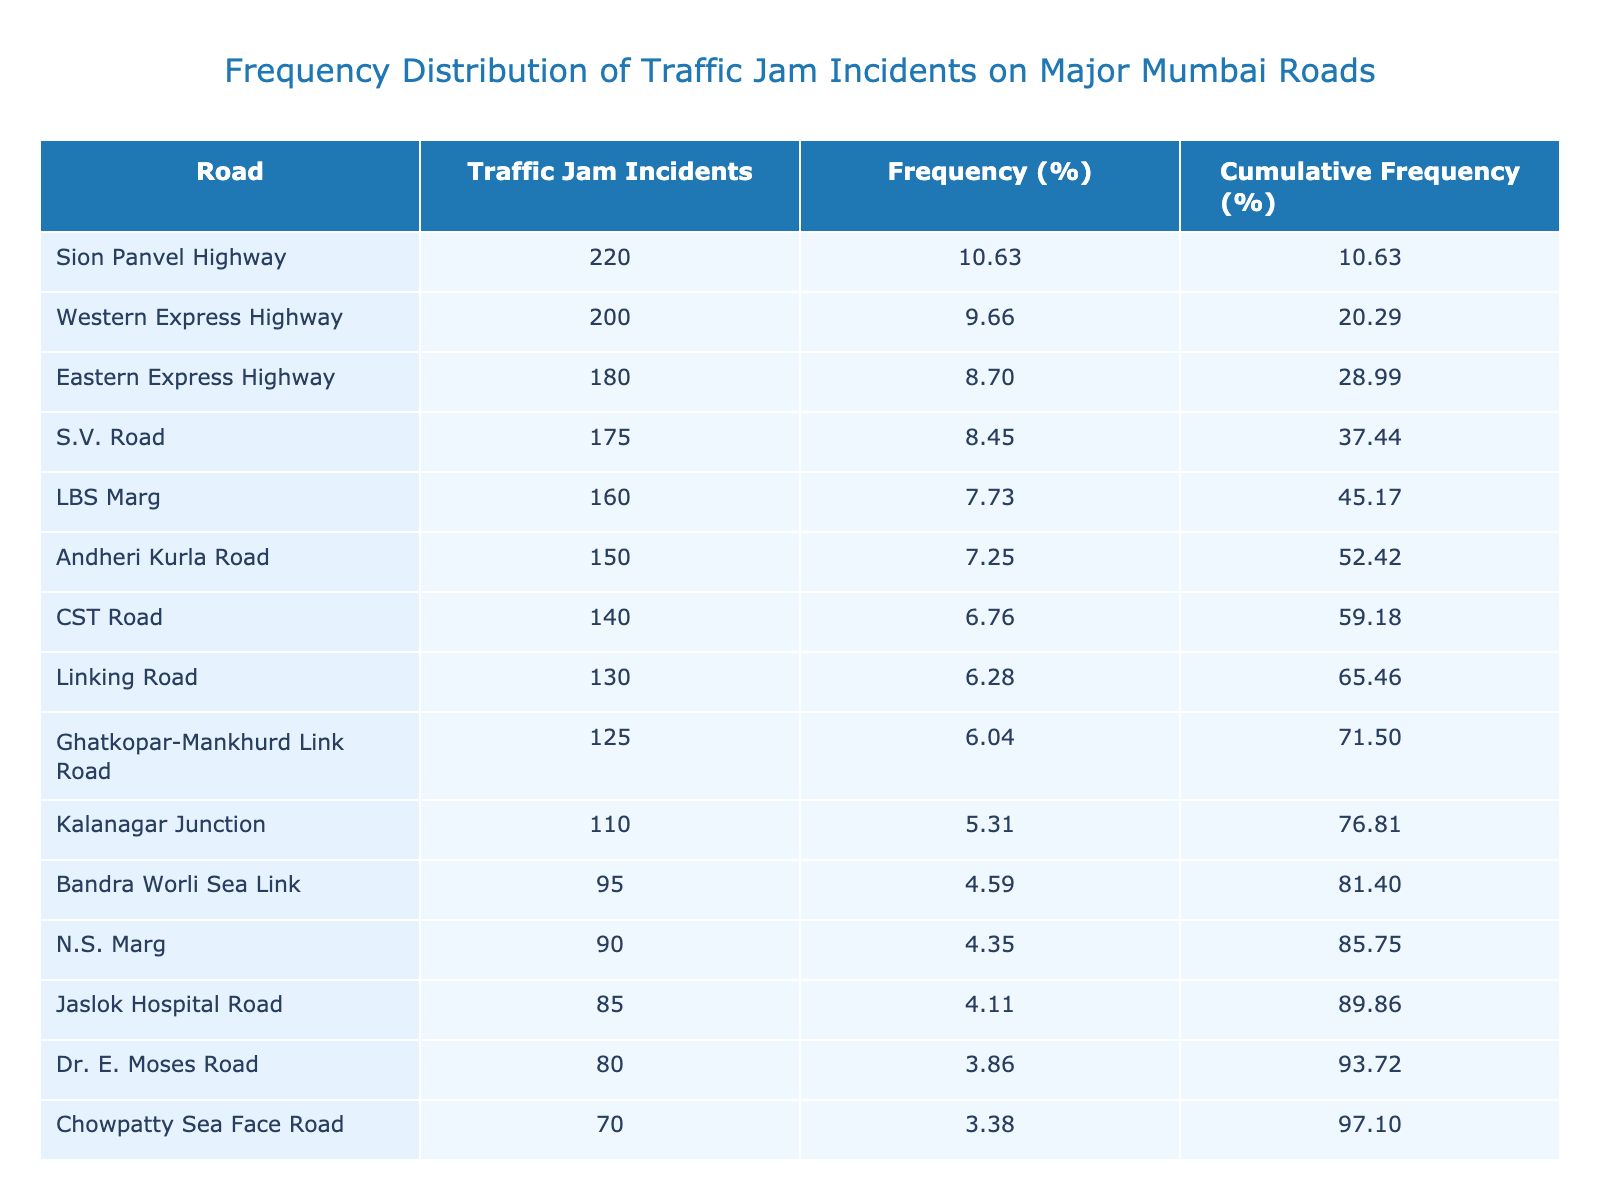What's the road with the highest number of traffic jam incidents? By looking at the Traffic Jam Incidents column, the highest value is 220, which corresponds to the Sion Panvel Highway.
Answer: Sion Panvel Highway How many traffic jam incidents were reported on the Western Express Highway? Referring to the Traffic Jam Incidents column, the Western Express Highway has 200 incidents listed.
Answer: 200 What is the total number of traffic jam incidents across all roads? To find the total, I add up all the incidents: 150 + 200 + 85 + 175 + 130 + 160 + 180 + 90 + 70 + 60 + 140 + 220 + 95 + 110 + 125 + 80 = 2010 incidents.
Answer: 2010 Which road has the lowest number of traffic jam incidents? The traffic incidents column shows that Marine Drive has the lowest value of 60 incidents.
Answer: Marine Drive Is the number of traffic jam incidents on Linking Road greater than 150? Looking at the Traffic Jam Incidents column, Linking Road has 130 incidents, which is less than 150, so the answer is no.
Answer: No What is the cumulative frequency percentage of incidents for the top three roads? The top three roads by incidents are Sion Panvel Highway (220), Western Express Highway (200), and Eastern Express Highway (180). Calculating their cumulative frequency percentages gives: 220/(2010)*100 + 200/(2010)*100 + 180/(2010)*100 = 10.95 + 9.95 + 8.96 = 29.86%.
Answer: 29.86 How many roads had more than 150 traffic jam incidents? Scanning the Traffic Jam Incidents column, the roads with more than 150 incidents are: Sion Panvel Highway (220), Western Express Highway (200), Eastern Express Highway (180), and LBS Marg (160), totaling four roads.
Answer: 4 What is the average frequency of traffic jam incidents across all the roads? The total number of incidents is 2010, and there are 16 roads. To find the average, I divide 2010 by 16, which equals 125.625.
Answer: 125.63 Are there more roads with traffic jam incidents below 100 or above 100? The roads below 100 are: Jaslok Hospital Road (85), N.S. Marg (90), Chowpatty Sea Face Road (70), and Marine Drive (60), which makes a total of four. For above 100, there are 12 roads. Since there are more roads above 100, the answer is yes.
Answer: Yes 